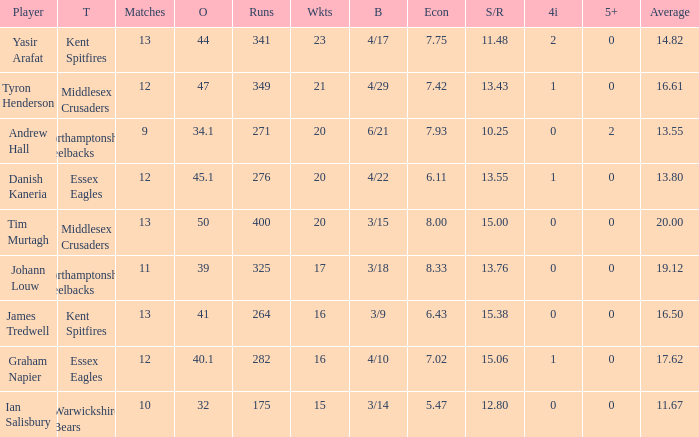How many matches are needed at a minimum to achieve 276 runs? 12.0. 